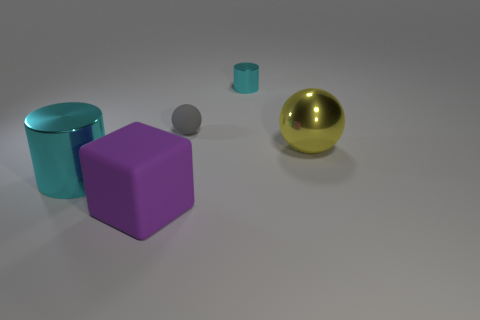Do the small metallic cylinder and the big cylinder have the same color?
Provide a succinct answer. Yes. What number of objects are tiny cyan metallic things that are on the right side of the purple rubber cube or green things?
Offer a very short reply. 1. What material is the small cyan cylinder?
Your response must be concise. Metal. Is the purple cube the same size as the gray thing?
Provide a short and direct response. No. How many spheres are either small shiny things or yellow shiny objects?
Make the answer very short. 1. The large thing right of the cyan thing behind the large cyan object is what color?
Provide a short and direct response. Yellow. Are there fewer purple blocks that are to the right of the gray sphere than yellow metallic objects that are behind the large purple cube?
Provide a short and direct response. Yes. Is the size of the purple matte block the same as the cyan cylinder right of the large purple block?
Your response must be concise. No. What is the shape of the metallic thing that is both on the left side of the big yellow metallic ball and to the right of the large rubber block?
Give a very brief answer. Cylinder. There is a sphere that is made of the same material as the big cylinder; what is its size?
Provide a short and direct response. Large. 